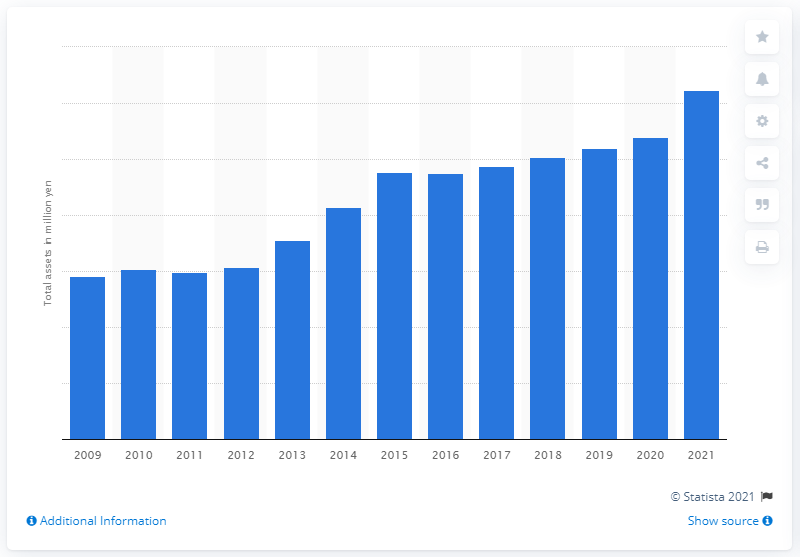Give some essential details in this illustration. In 2021, Toyota's total assets were 62,267,140. 